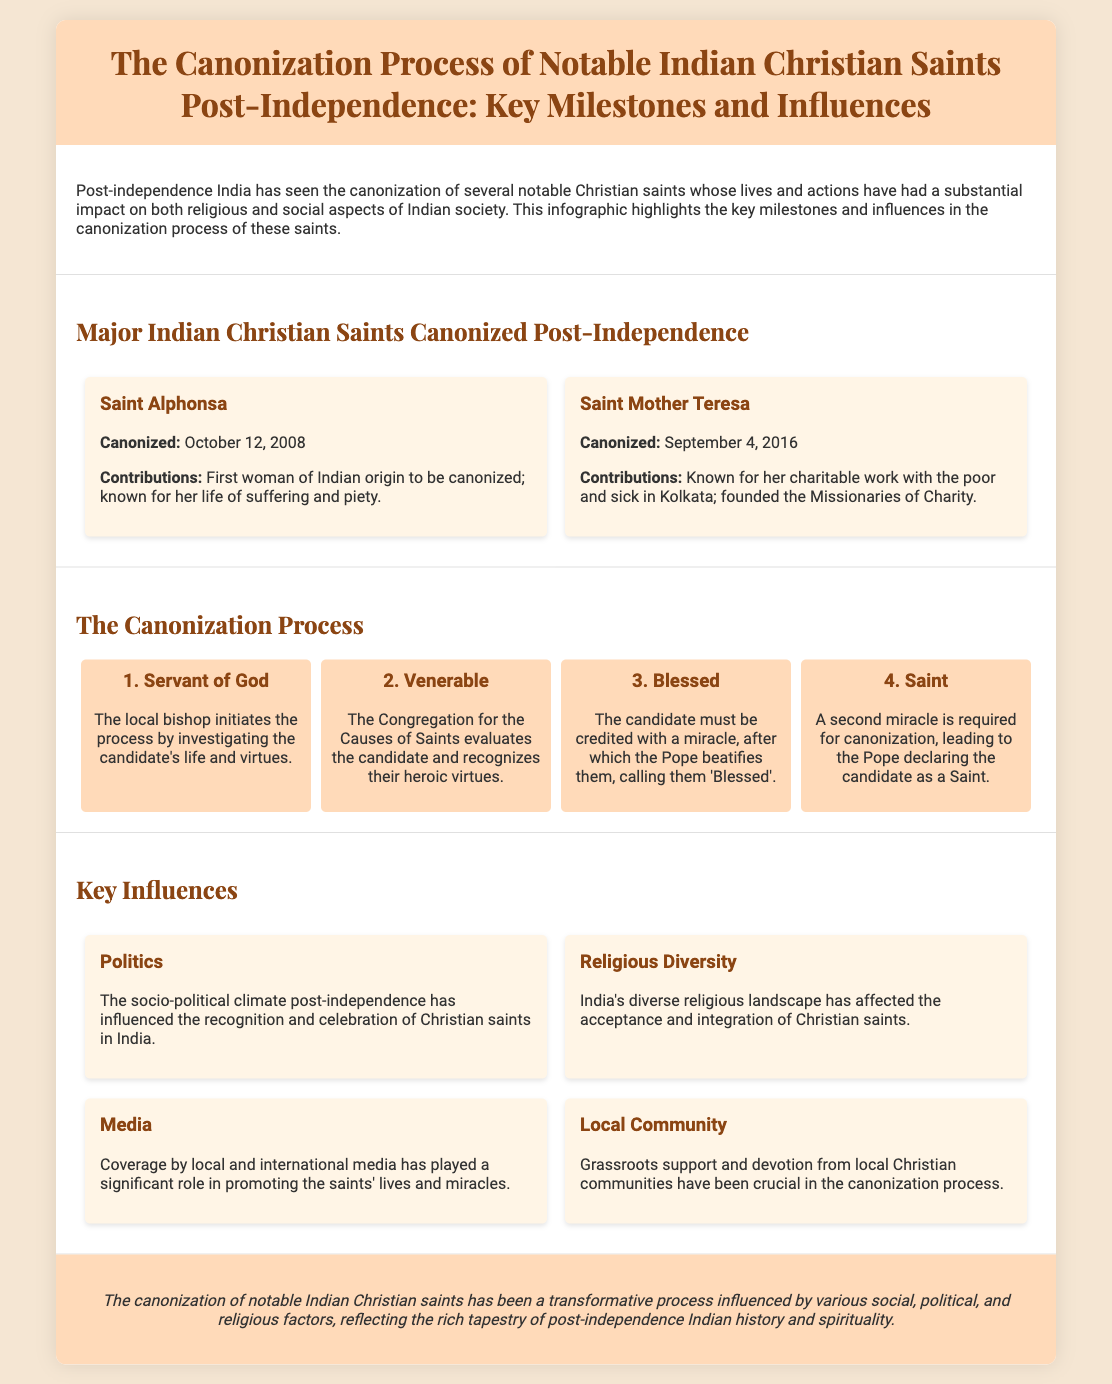what is the name of the first Indian woman to be canonized? The document mentions that Saint Alphonsa is the first woman of Indian origin to be canonized.
Answer: Saint Alphonsa when was Saint Mother Teresa canonized? According to the document, Saint Mother Teresa was canonized on September 4, 2016.
Answer: September 4, 2016 what is the first step in the canonization process? The infographic outlines that the first step is 'Servant of God', initiated by the local bishop.
Answer: Servant of God how many miracles are required for canonization? The document states that a second miracle is required for canonization.
Answer: Two miracles what are the four steps in the canonization process? The document lists the steps: Servant of God, Venerable, Blessed, and Saint.
Answer: Servant of God, Venerable, Blessed, Saint which factor influences the recognition of Christian saints in post-independence India? The document indicates that the socio-political climate post-independence influences the recognition of Christian saints.
Answer: Politics what role does media play in the canonization process? The infographic states that media coverage plays a significant role in promoting the saints' lives and miracles.
Answer: Promoting lives and miracles how has local community affected canonization? The document suggests that grassroots support and devotion from local Christian communities have been crucial in the process.
Answer: Crucial support and devotion what is the overall theme of the document? The conclusion summarizes that the canonization reflects the rich tapestry of post-independence Indian history and spirituality.
Answer: History and spirituality 